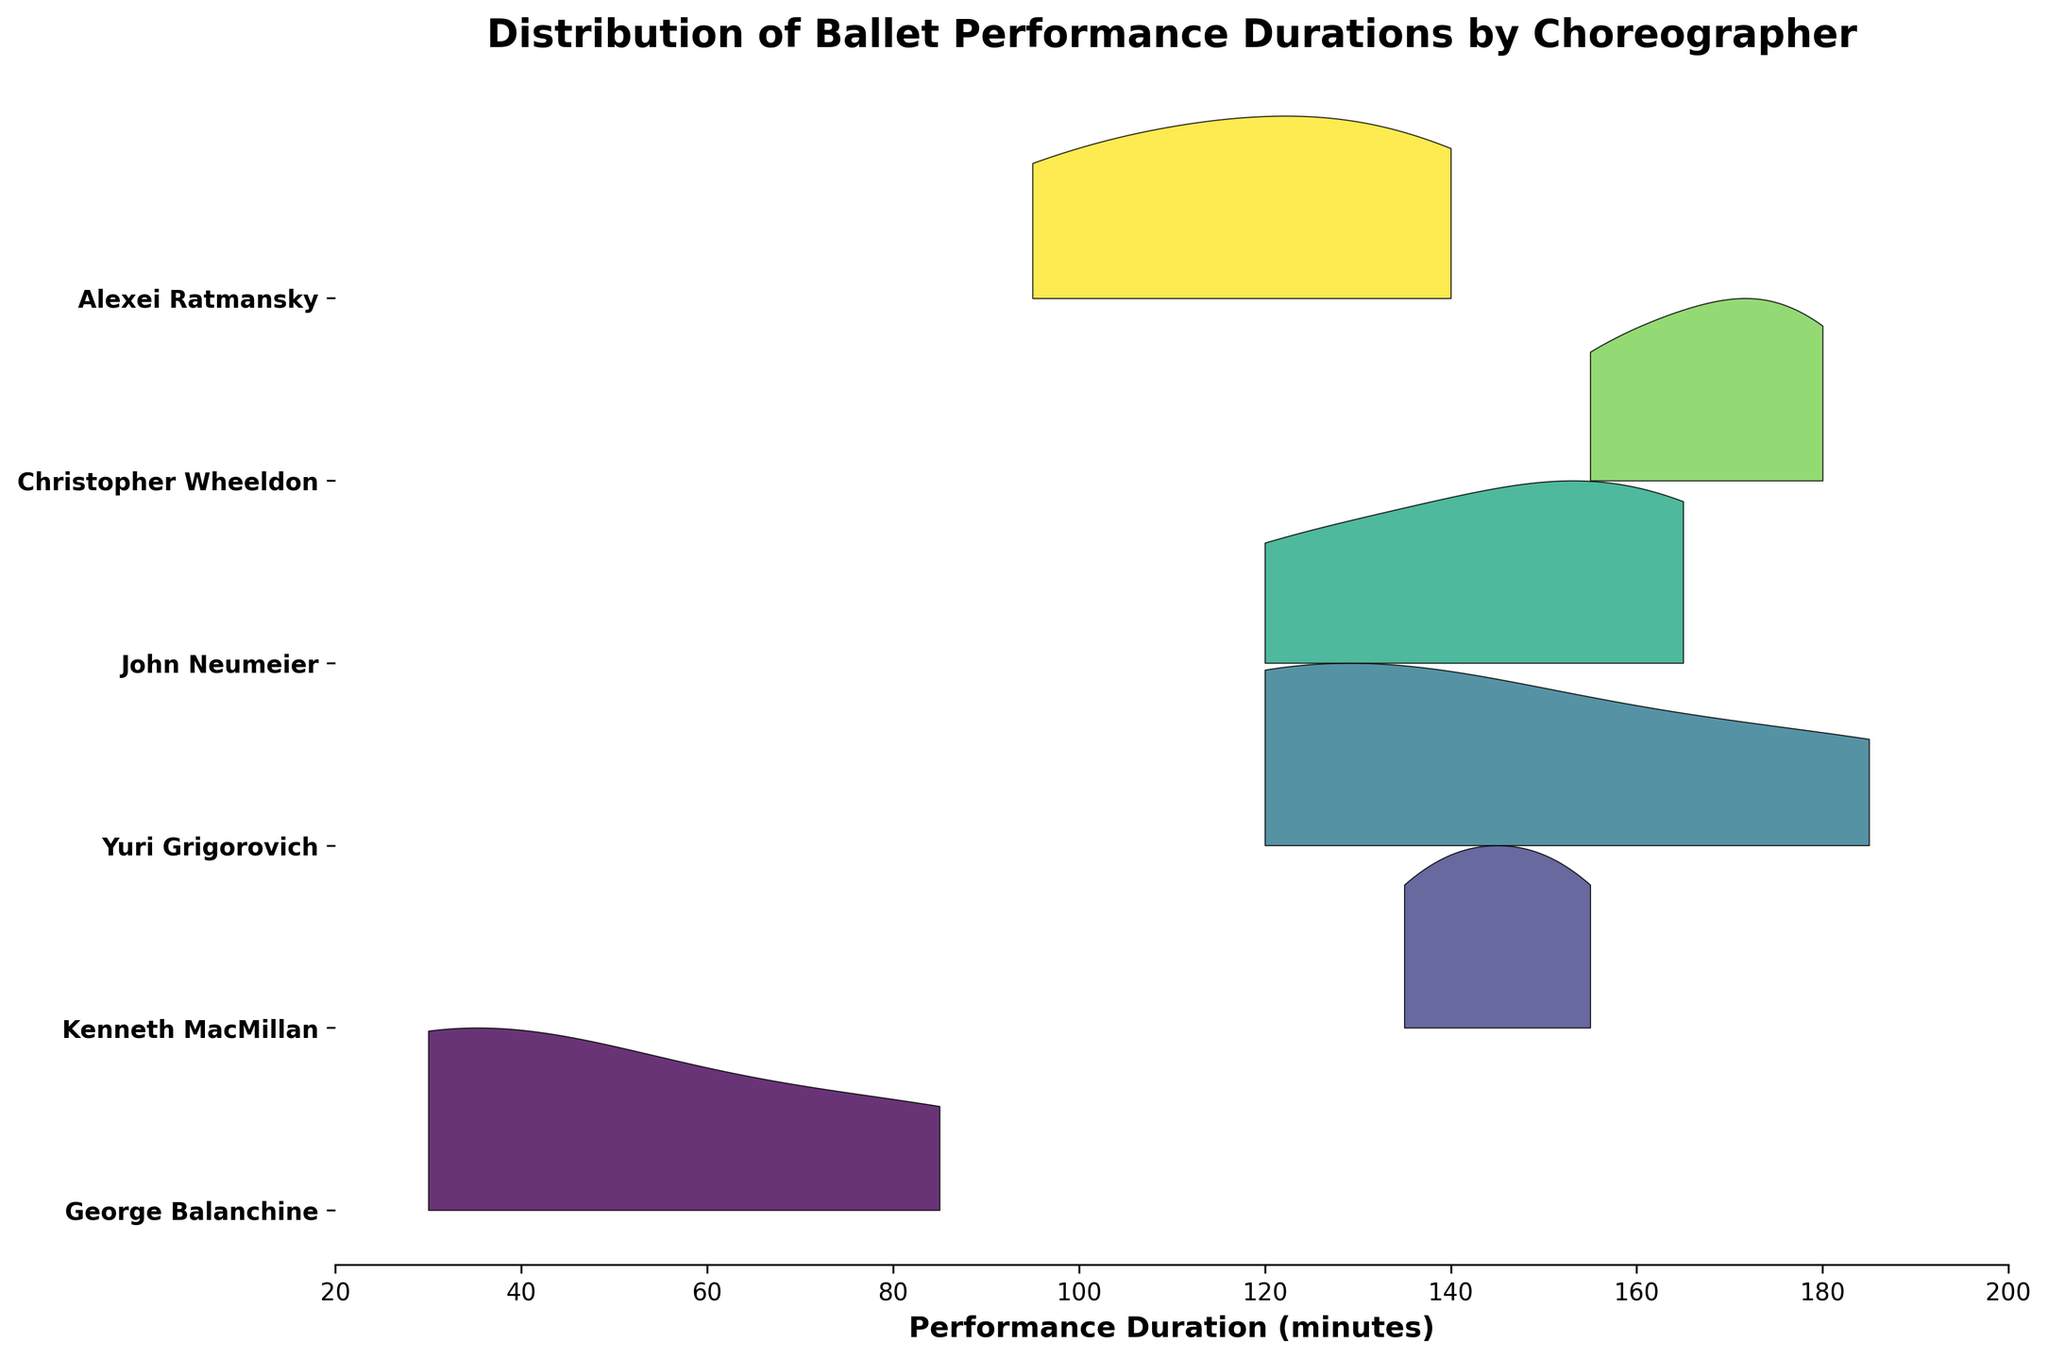What is the title of the plot? The title is usually displayed at the top of the plot. In this case, the title is given directly in the plot.
Answer: Distribution of Ballet Performance Durations by Choreographer Which choreographer has the longest performance duration? From the plot, find the highest maximum duration on the x-axis. The one with the peak furthest to the right usually indicates the longest performance. The longest duration appears with Christopher Wheeldon.
Answer: Christopher Wheeldon What is the range of performance durations covered in the plot? The x-axis displays the range of performance durations. The plot sets the x-axis limits from 20 to 200 minutes.
Answer: 20 to 200 minutes Which choreographer has the performance with the shortest duration? The shortest duration can be found by identifying the leftmost peak in the plot. George Balanchine has the shortest performance duration.
Answer: George Balanchine How many choreographers are compared in the plot? The plot shows different ridgelines, each representing a different choreographer. Counting the unique names on the y-axis labels will give the answer.
Answer: 6 Which two choreographers have a significant overlap in their performance durations? To determine overlap, look for regions where the ridgelines of two choreographers intersect or share similar values. Alexei Ratmansky and John Neumeier have overlapping distributions.
Answer: Alexei Ratmansky and John Neumeier What is the shortest performance duration for George Balanchine? Find the leftmost peak in the ridgeline associated with George Balanchine. The duration at this peak represents the shortest performance.
Answer: 30 minutes Which choreographer's performances are generally the shortest in duration? Examine the overall shape and leftmost limits of the ridgelines. George Balanchine's ridgeline is primarily towards the left, indicating shorter durations overall.
Answer: George Balanchine For John Neumeier, what is the max duration of his performances? Look at the rightmost peak of John Neumeier's ridgeline. The corresponding x-axis value is the maximum duration of his performances.
Answer: 165 minutes How does the spread of Yuri Grigorovich's performance durations compare to Kenneth MacMillan's? Analyze the width of their respective ridgelines. A wider ridgeline indicates a broader spread. Kenneth MacMillan's performances have a wider spread compared to Yuri Grigorovich's.
Answer: Kenneth MacMillan has a wider spread 